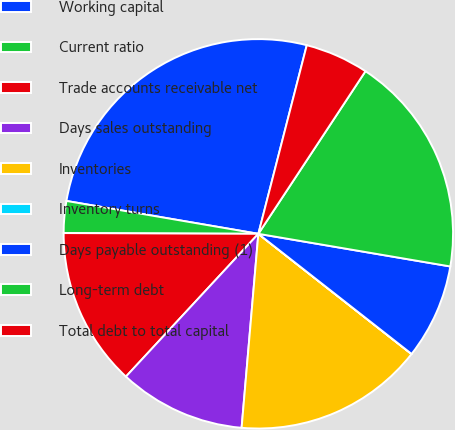Convert chart to OTSL. <chart><loc_0><loc_0><loc_500><loc_500><pie_chart><fcel>Working capital<fcel>Current ratio<fcel>Trade accounts receivable net<fcel>Days sales outstanding<fcel>Inventories<fcel>Inventory turns<fcel>Days payable outstanding (1)<fcel>Long-term debt<fcel>Total debt to total capital<nl><fcel>26.3%<fcel>2.64%<fcel>13.16%<fcel>10.53%<fcel>15.78%<fcel>0.01%<fcel>7.9%<fcel>18.41%<fcel>5.27%<nl></chart> 